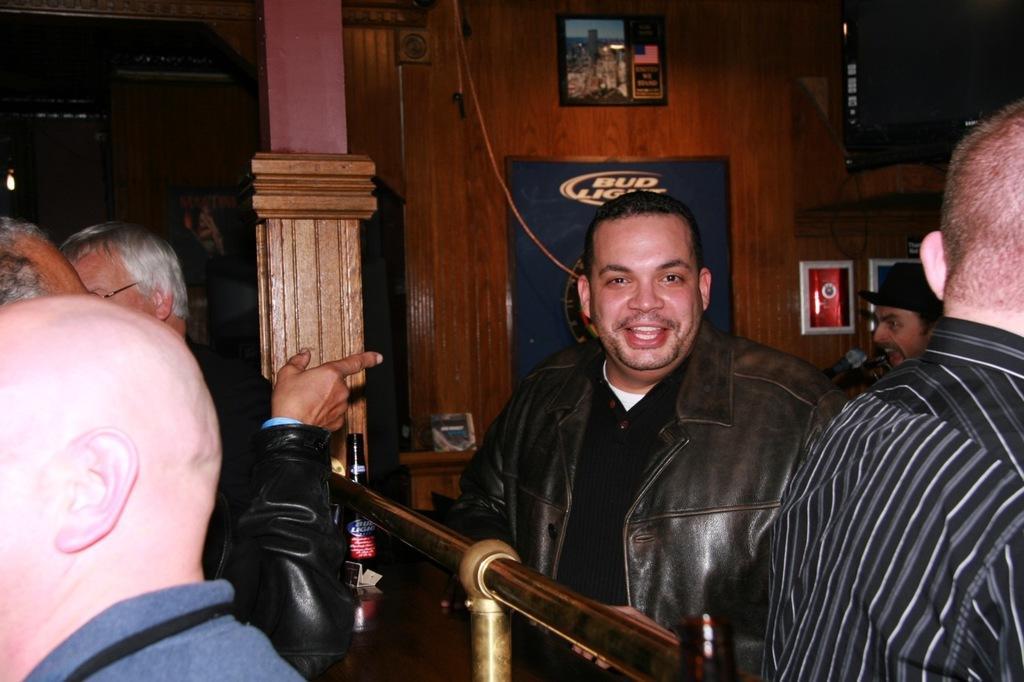Please provide a concise description of this image. In this image we can see a group of people wearing dress are standing. In the foreground we can see bottles placed on table, metal poles. In the background, we can see a microphone, photo frames on the wall, a book placed on the rack and a pillar. 